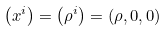Convert formula to latex. <formula><loc_0><loc_0><loc_500><loc_500>\left ( x ^ { i } \right ) = \left ( \rho ^ { i } \right ) = ( \rho , 0 , 0 )</formula> 